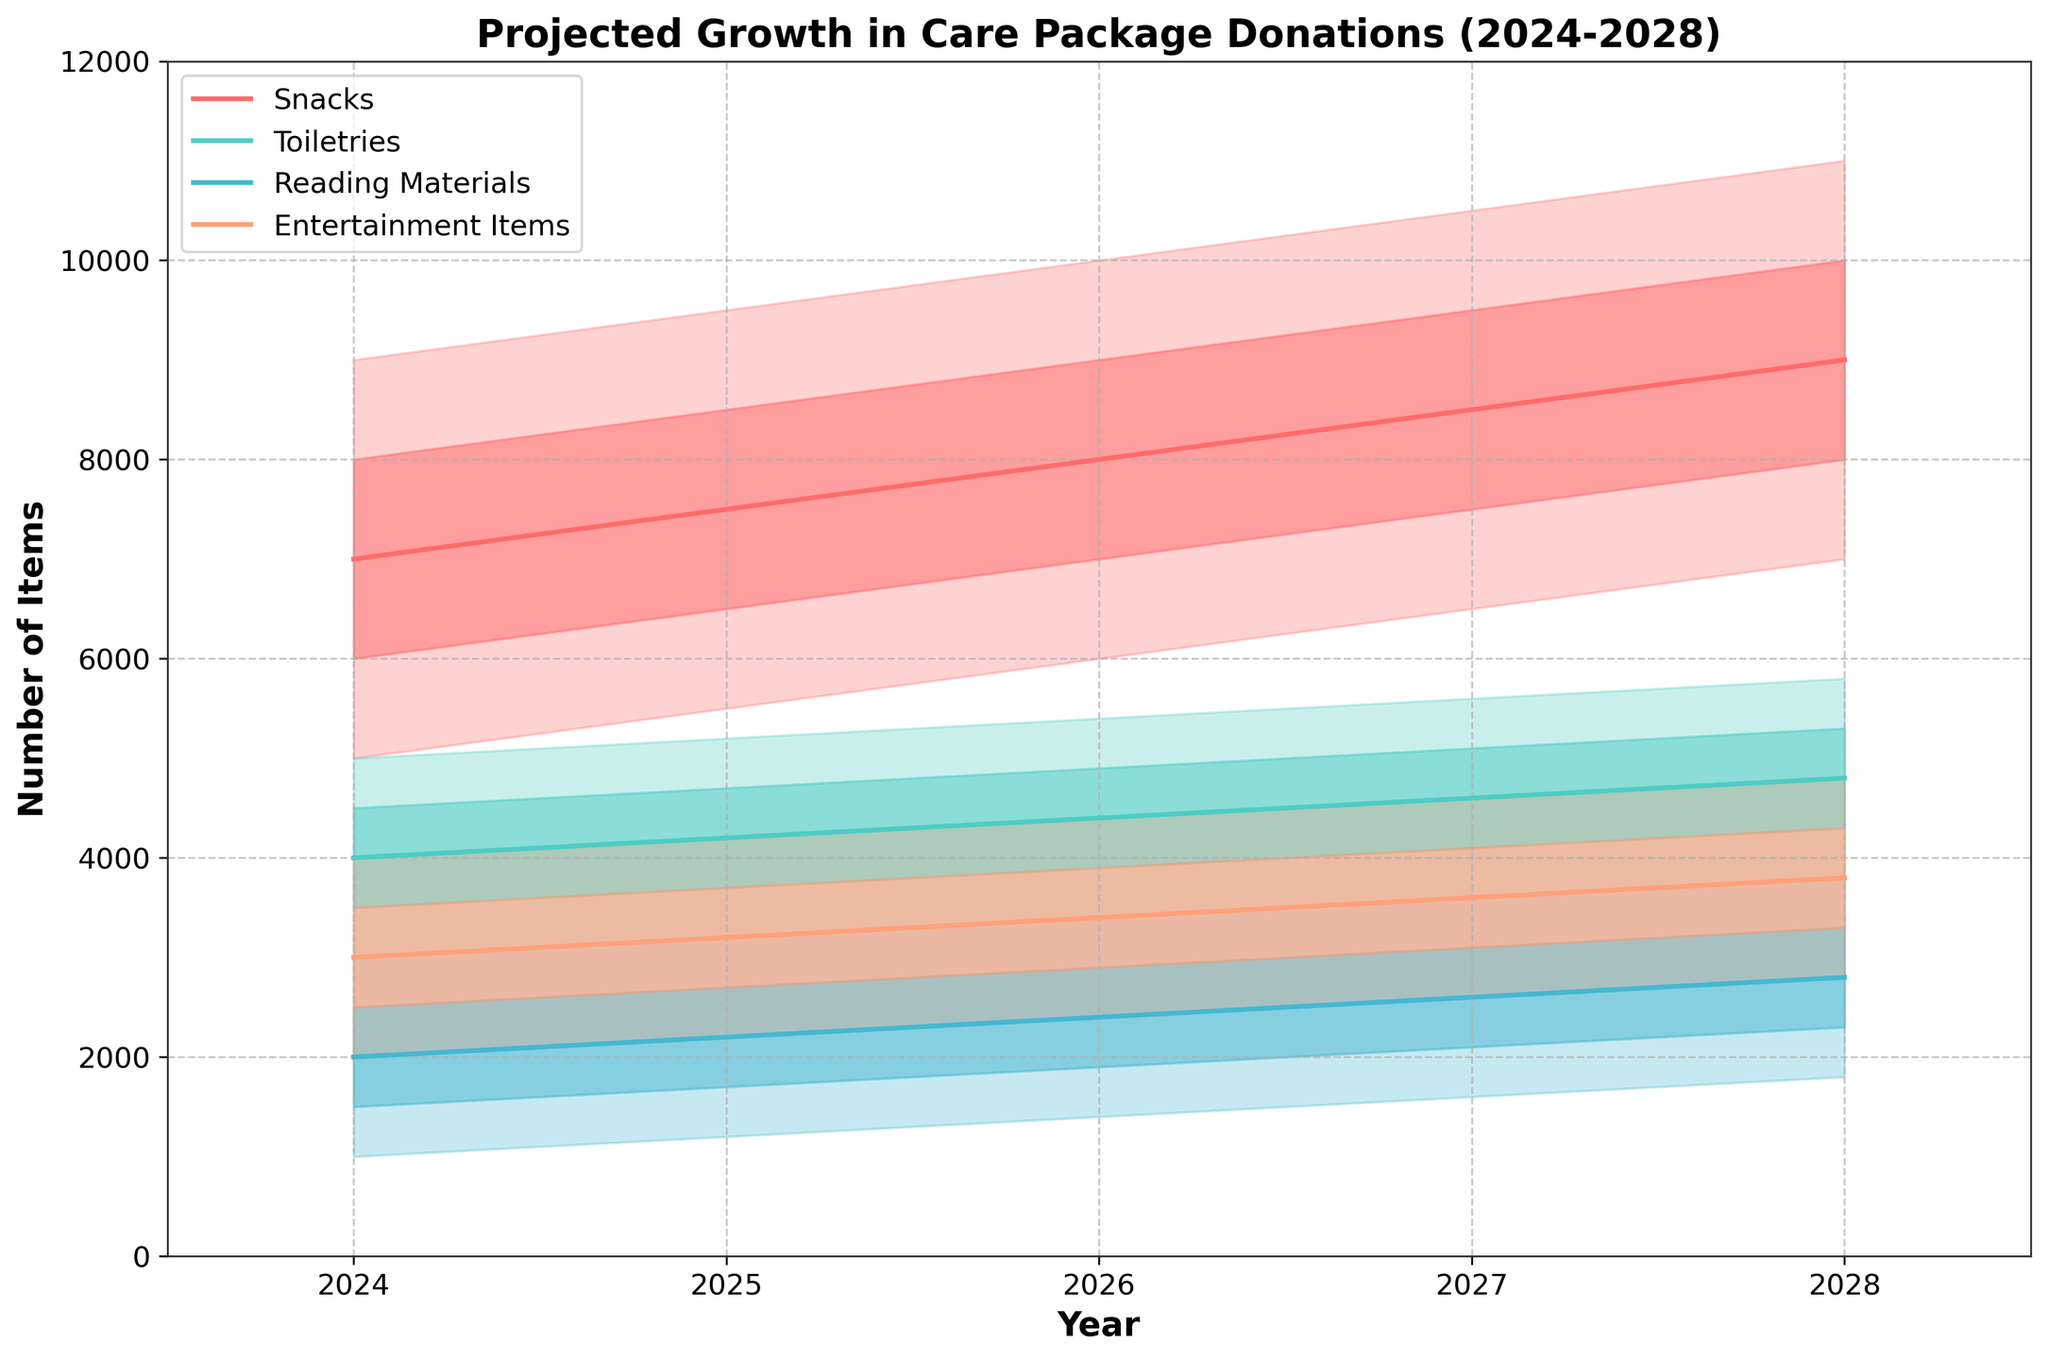What is the projected number of Toiletries donations for the year 2025 at the median growth rate? Check the mid-value for Toiletries in 2025. The figure shows the median growth value for each category and year.
Answer: 4200 What category is projected to see the highest number of donations in 2027 at the high growth rate? Compare the high growth rates of all categories for 2027. Look for the highest value among the projected values at the high growth rate.
Answer: Snacks By how much are the mid-high projection values of Snacks in 2028 higher than in 2024? Identify the mid-high values for Snacks in 2028 and 2024, then subtract 2024's value from 2028's.
Answer: 2000 (10000 - 8000) Which category shows the smallest range between the low and high projections in 2026? For each category in 2026, calculate the difference between the low and high projections. The smallest difference will indicate the smallest range.
Answer: Toiletries What is the average projected growth for Reading Materials between 2024 and 2028 at the mid value? Sum the mid values for Reading Materials from 2024 to 2028 and divide by the number of years (5 years).
Answer: 2400 ((2000 + 2200 + 2400 + 2600 + 2800) / 5) Which category exhibits the largest potential growth variation (difference between low and high) in 2028? Calculate the variation for each category in 2028 by subtracting the low value from the high value. Identify the largest difference.
Answer: Snacks How many years in the projection period do Snacks have a median value greater than 8000? Check the mid values for Snacks from 2024 to 2028, count the years where the mid value exceeds 8000.
Answer: 1 year (2028) Do Toiletries have a higher mid-high projected growth in 2026 compared to Entertainment Items in 2024? Compare the mid-high value for Toiletries in 2026 with the mid-high value for Entertainment Items in 2024.
Answer: Yes (4900 vs. 3500) What is the increase in the median value of Entertainment Items from 2025 to 2027? Find the median values for Entertainment Items in 2025 and 2027, then subtract the 2025 value from the 2027 value.
Answer: 400 (3600 - 3200) Which year shows the smallest projected range for Reading Materials, based on median values across all years? Compare the range (difference between high and low) of median values for Reading Materials across each year and identify the year with the smallest range.
Answer: 2024 